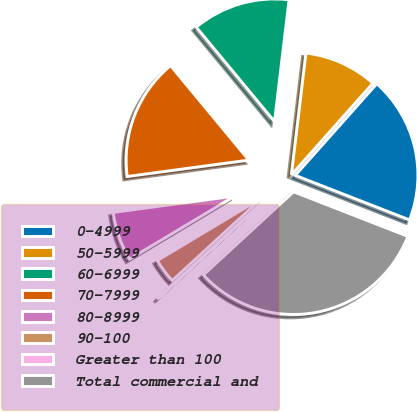Convert chart. <chart><loc_0><loc_0><loc_500><loc_500><pie_chart><fcel>0-4999<fcel>50-5999<fcel>60-6999<fcel>70-7999<fcel>80-8999<fcel>90-100<fcel>Greater than 100<fcel>Total commercial and<nl><fcel>19.34%<fcel>9.68%<fcel>12.9%<fcel>16.12%<fcel>6.46%<fcel>3.24%<fcel>0.02%<fcel>32.23%<nl></chart> 